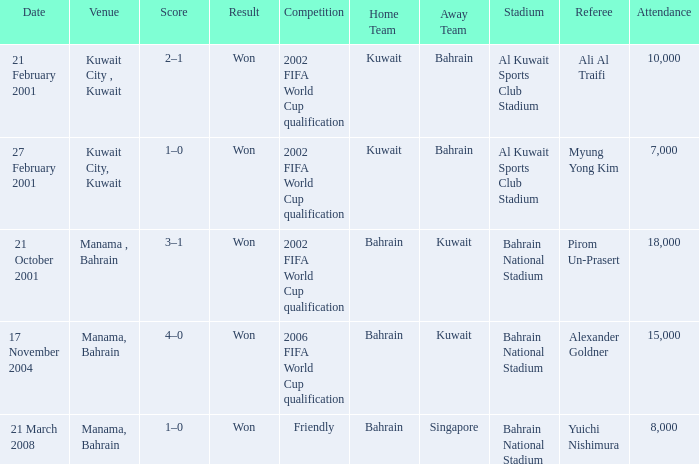On which date was the match in Manama, Bahrain? 21 October 2001, 17 November 2004, 21 March 2008. 